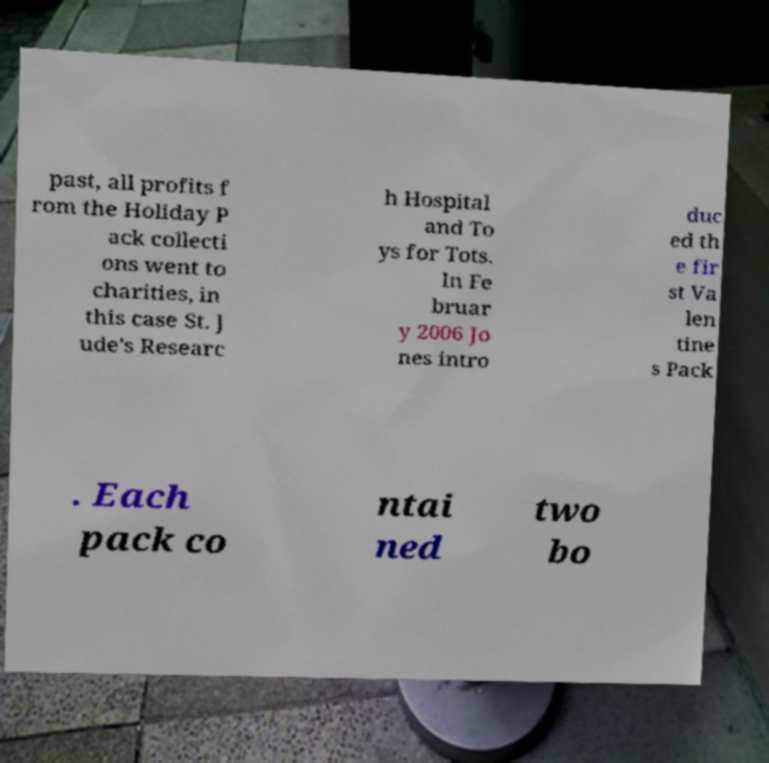Please identify and transcribe the text found in this image. past, all profits f rom the Holiday P ack collecti ons went to charities, in this case St. J ude's Researc h Hospital and To ys for Tots. In Fe bruar y 2006 Jo nes intro duc ed th e fir st Va len tine s Pack . Each pack co ntai ned two bo 